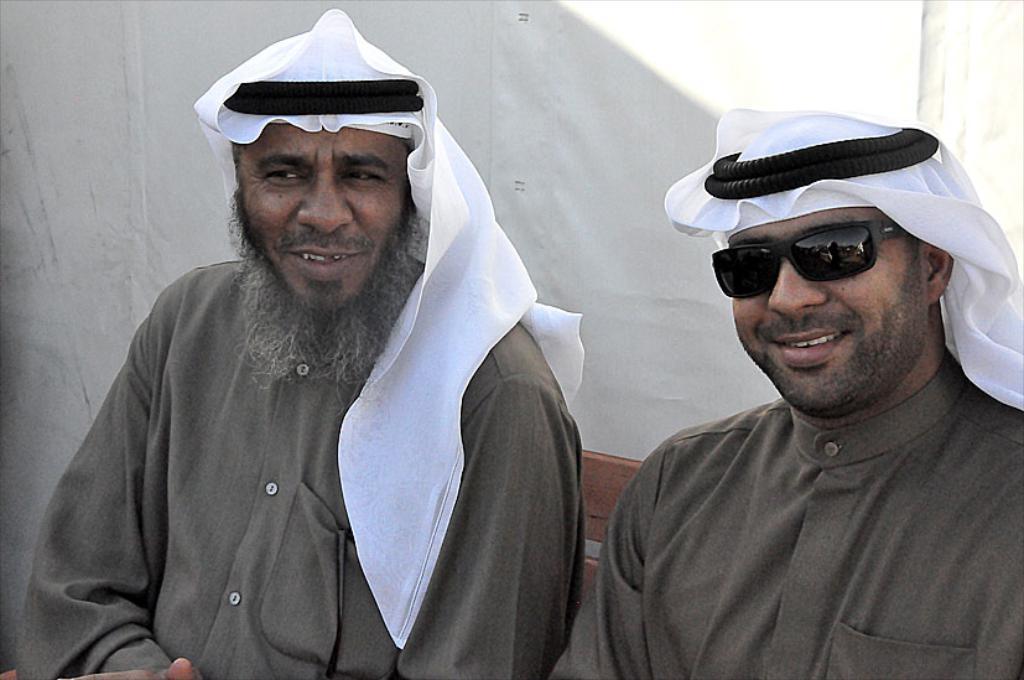How would you summarize this image in a sentence or two? There are two men sitting and smiling. They wore a arabic head turban and kurta. In the background, that looks like a cloth, which is white in color. 